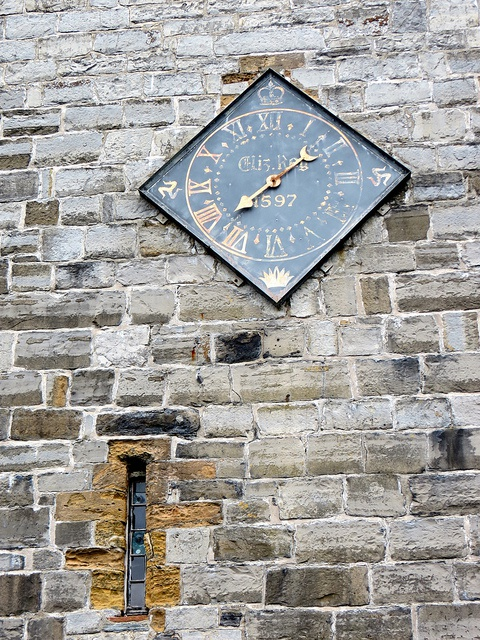Describe the objects in this image and their specific colors. I can see a clock in darkgray, lightgray, and black tones in this image. 